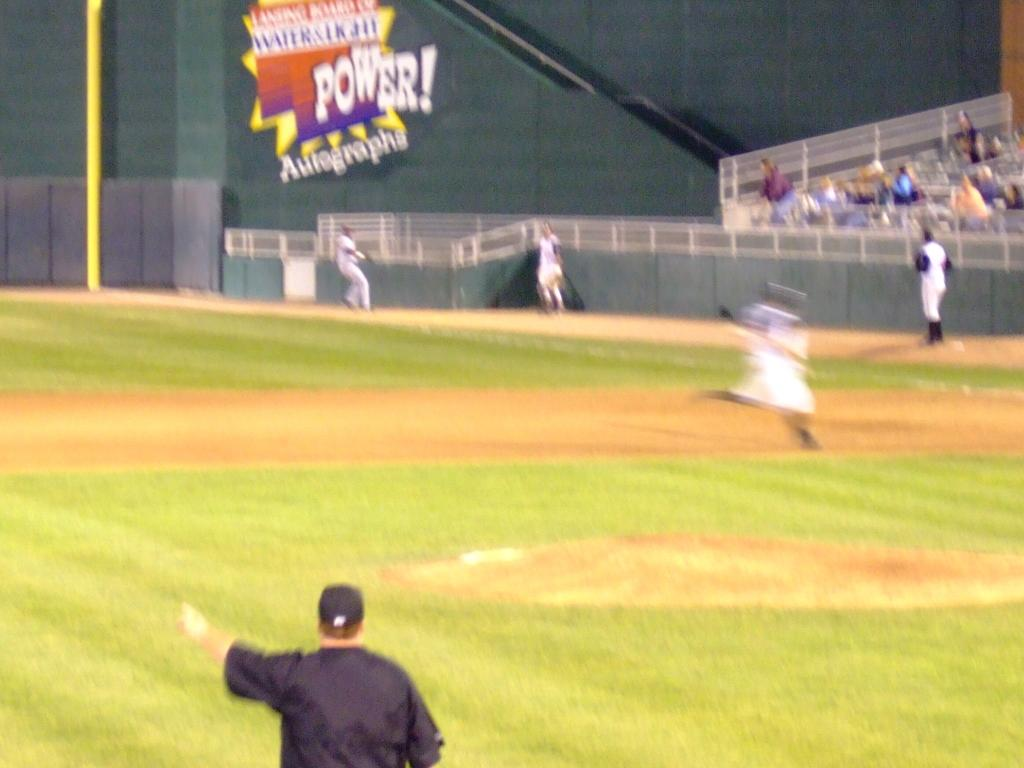Provide a one-sentence caption for the provided image. A shot of a baseball field with A Power! Autographs advertisement on the outfield wall. 